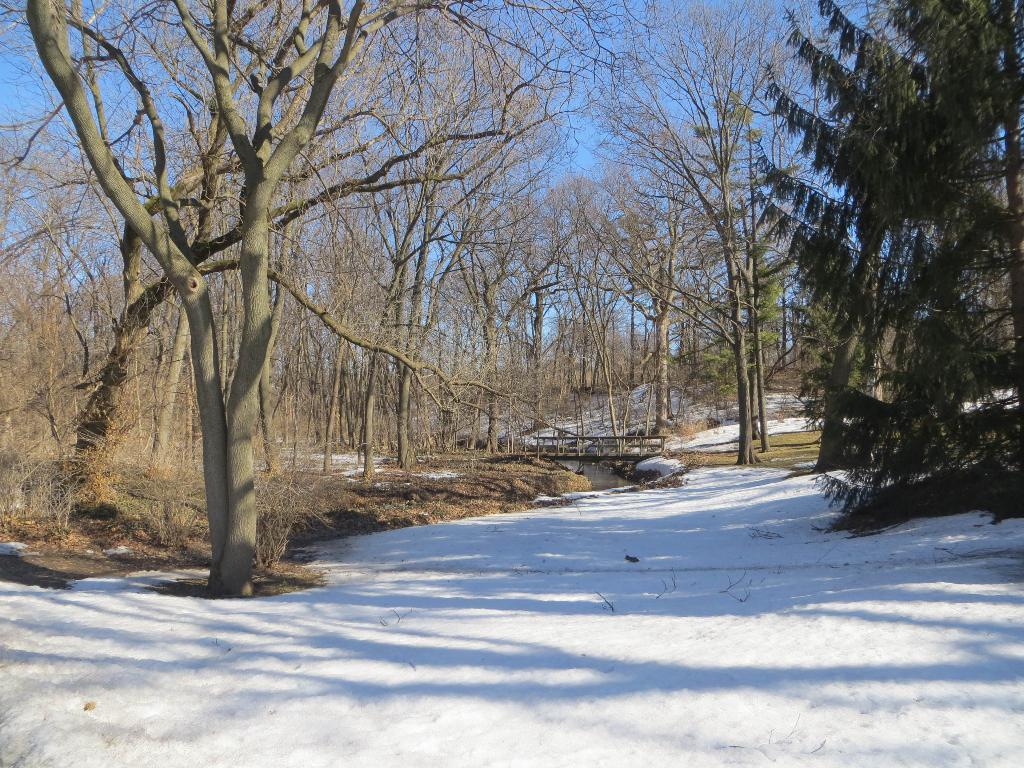What type of weather condition is depicted in the image? There is snow in the image. What can be seen in the distance in the image? There are trees in the background of the image. What is visible above the trees in the image? The sky is visible in the background of the image. What type of cloth is being used to generate profit in the image? There is no cloth or reference to profit in the image; it depicts a snowy scene with trees and the sky in the background. 